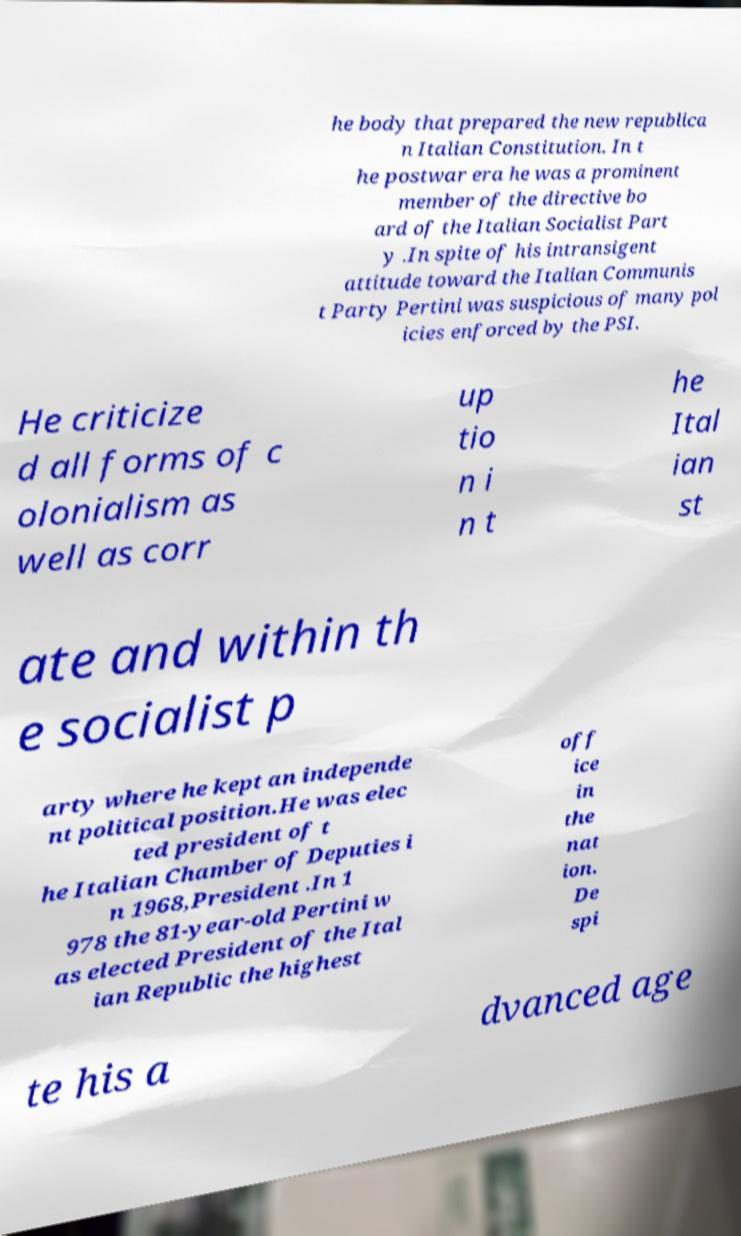Could you assist in decoding the text presented in this image and type it out clearly? he body that prepared the new republica n Italian Constitution. In t he postwar era he was a prominent member of the directive bo ard of the Italian Socialist Part y .In spite of his intransigent attitude toward the Italian Communis t Party Pertini was suspicious of many pol icies enforced by the PSI. He criticize d all forms of c olonialism as well as corr up tio n i n t he Ital ian st ate and within th e socialist p arty where he kept an independe nt political position.He was elec ted president of t he Italian Chamber of Deputies i n 1968,President .In 1 978 the 81-year-old Pertini w as elected President of the Ital ian Republic the highest off ice in the nat ion. De spi te his a dvanced age 